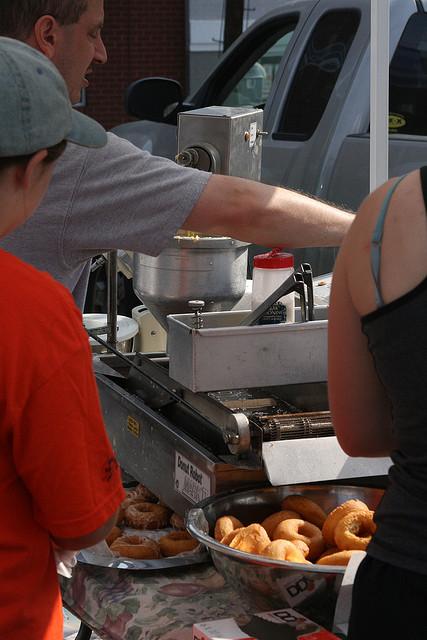What is being prepared?
Be succinct. Donuts. What do they call the way she is cooking?
Be succinct. Frying. What is cooking?
Give a very brief answer. Donuts. What kind of machine is this guy running?
Quick response, please. Donut. How many people are visible?
Give a very brief answer. 3. 